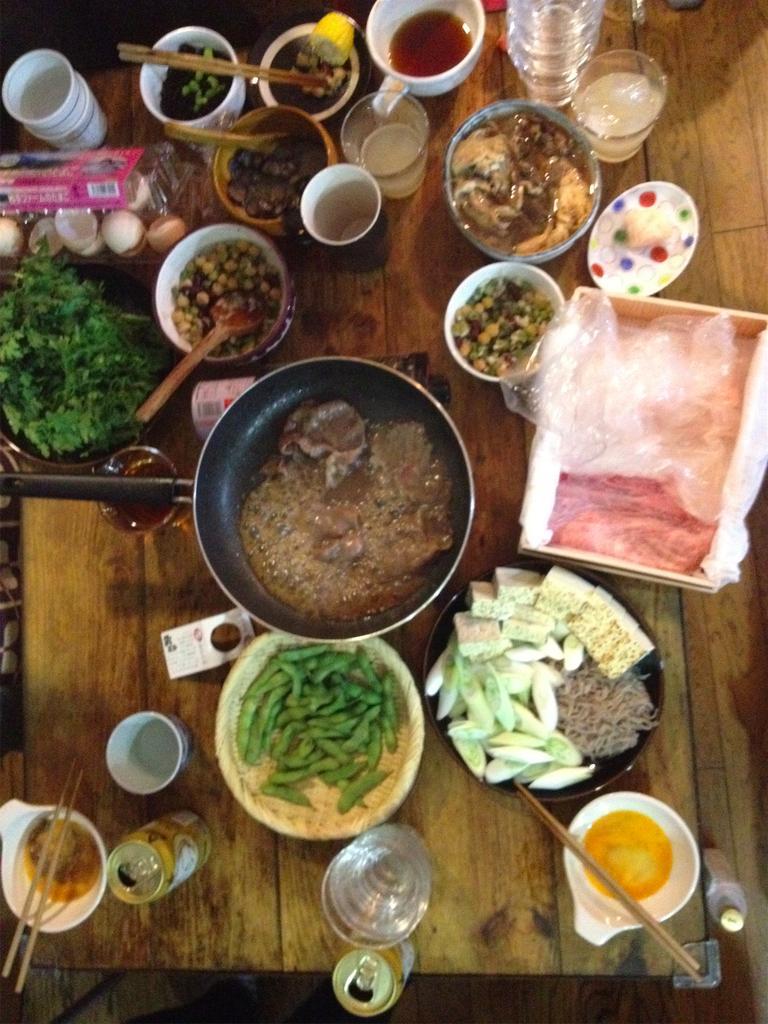Describe this image in one or two sentences. In this image we can see one wooden table, some bowls with good of food, one pan with food, some glasses with liquids, one spoon in the bowel, some chopsticks, some cups with liquids and some objects on the table. 